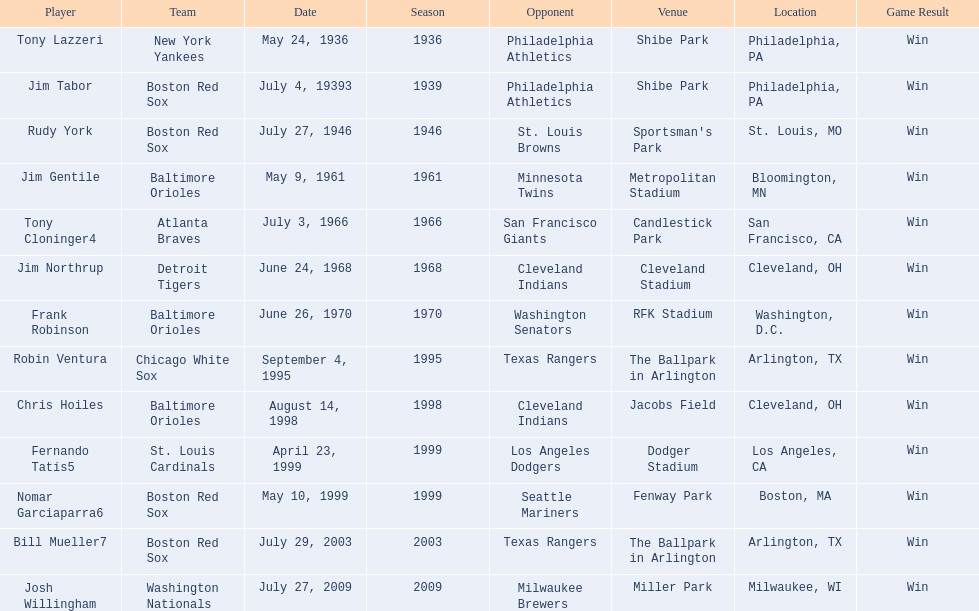Who was the opponent for the boston red sox on july 27, 1946? St. Louis Browns. 